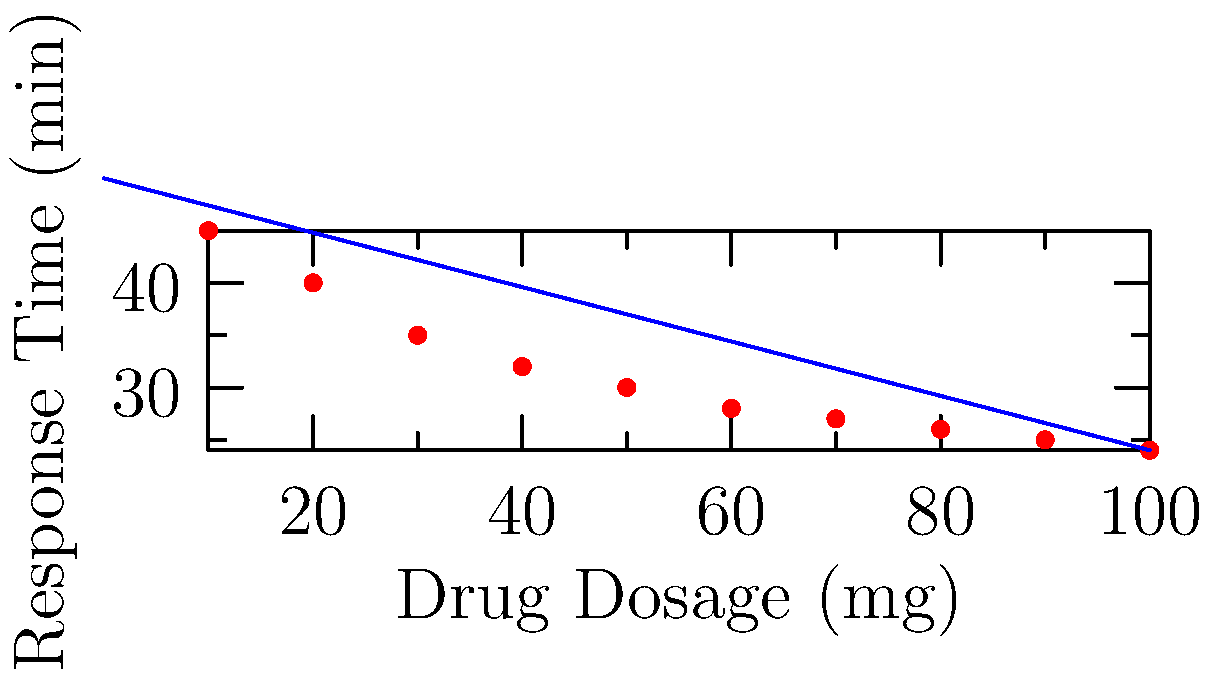Based on the scatter plot of drug dosage vs. patient response time, what type of relationship is observed between the variables, and what is the approximate slope of the trend line? To answer this question, we need to analyze the scatter plot and the trend line:

1. Relationship type:
   - As the drug dosage (x-axis) increases, the response time (y-axis) decreases.
   - The points form a pattern that moves from the upper left to the lower right.
   - This indicates a negative or inverse relationship between drug dosage and response time.

2. Slope calculation:
   - The slope of a line is generally calculated as $\frac{\text{change in y}}{\text{change in x}}$.
   - We can estimate this using two points on the trend line:
     - At x = 0, y ≈ 50
     - At x = 100, y ≈ 24
   - Slope = $\frac{24 - 50}{100 - 0} = \frac{-26}{100} = -0.26$

3. Interpretation:
   - The negative slope (-0.26) confirms the inverse relationship.
   - It suggests that for every 1 mg increase in drug dosage, the response time decreases by approximately 0.26 minutes.
Answer: Inverse relationship; -0.26 